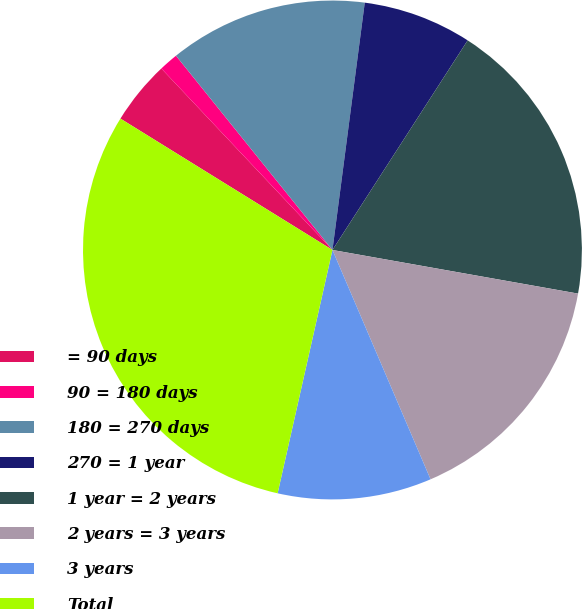Convert chart to OTSL. <chart><loc_0><loc_0><loc_500><loc_500><pie_chart><fcel>= 90 days<fcel>90 = 180 days<fcel>180 = 270 days<fcel>270 = 1 year<fcel>1 year = 2 years<fcel>2 years = 3 years<fcel>3 years<fcel>Total<nl><fcel>4.14%<fcel>1.24%<fcel>12.86%<fcel>7.05%<fcel>18.68%<fcel>15.77%<fcel>9.96%<fcel>30.3%<nl></chart> 